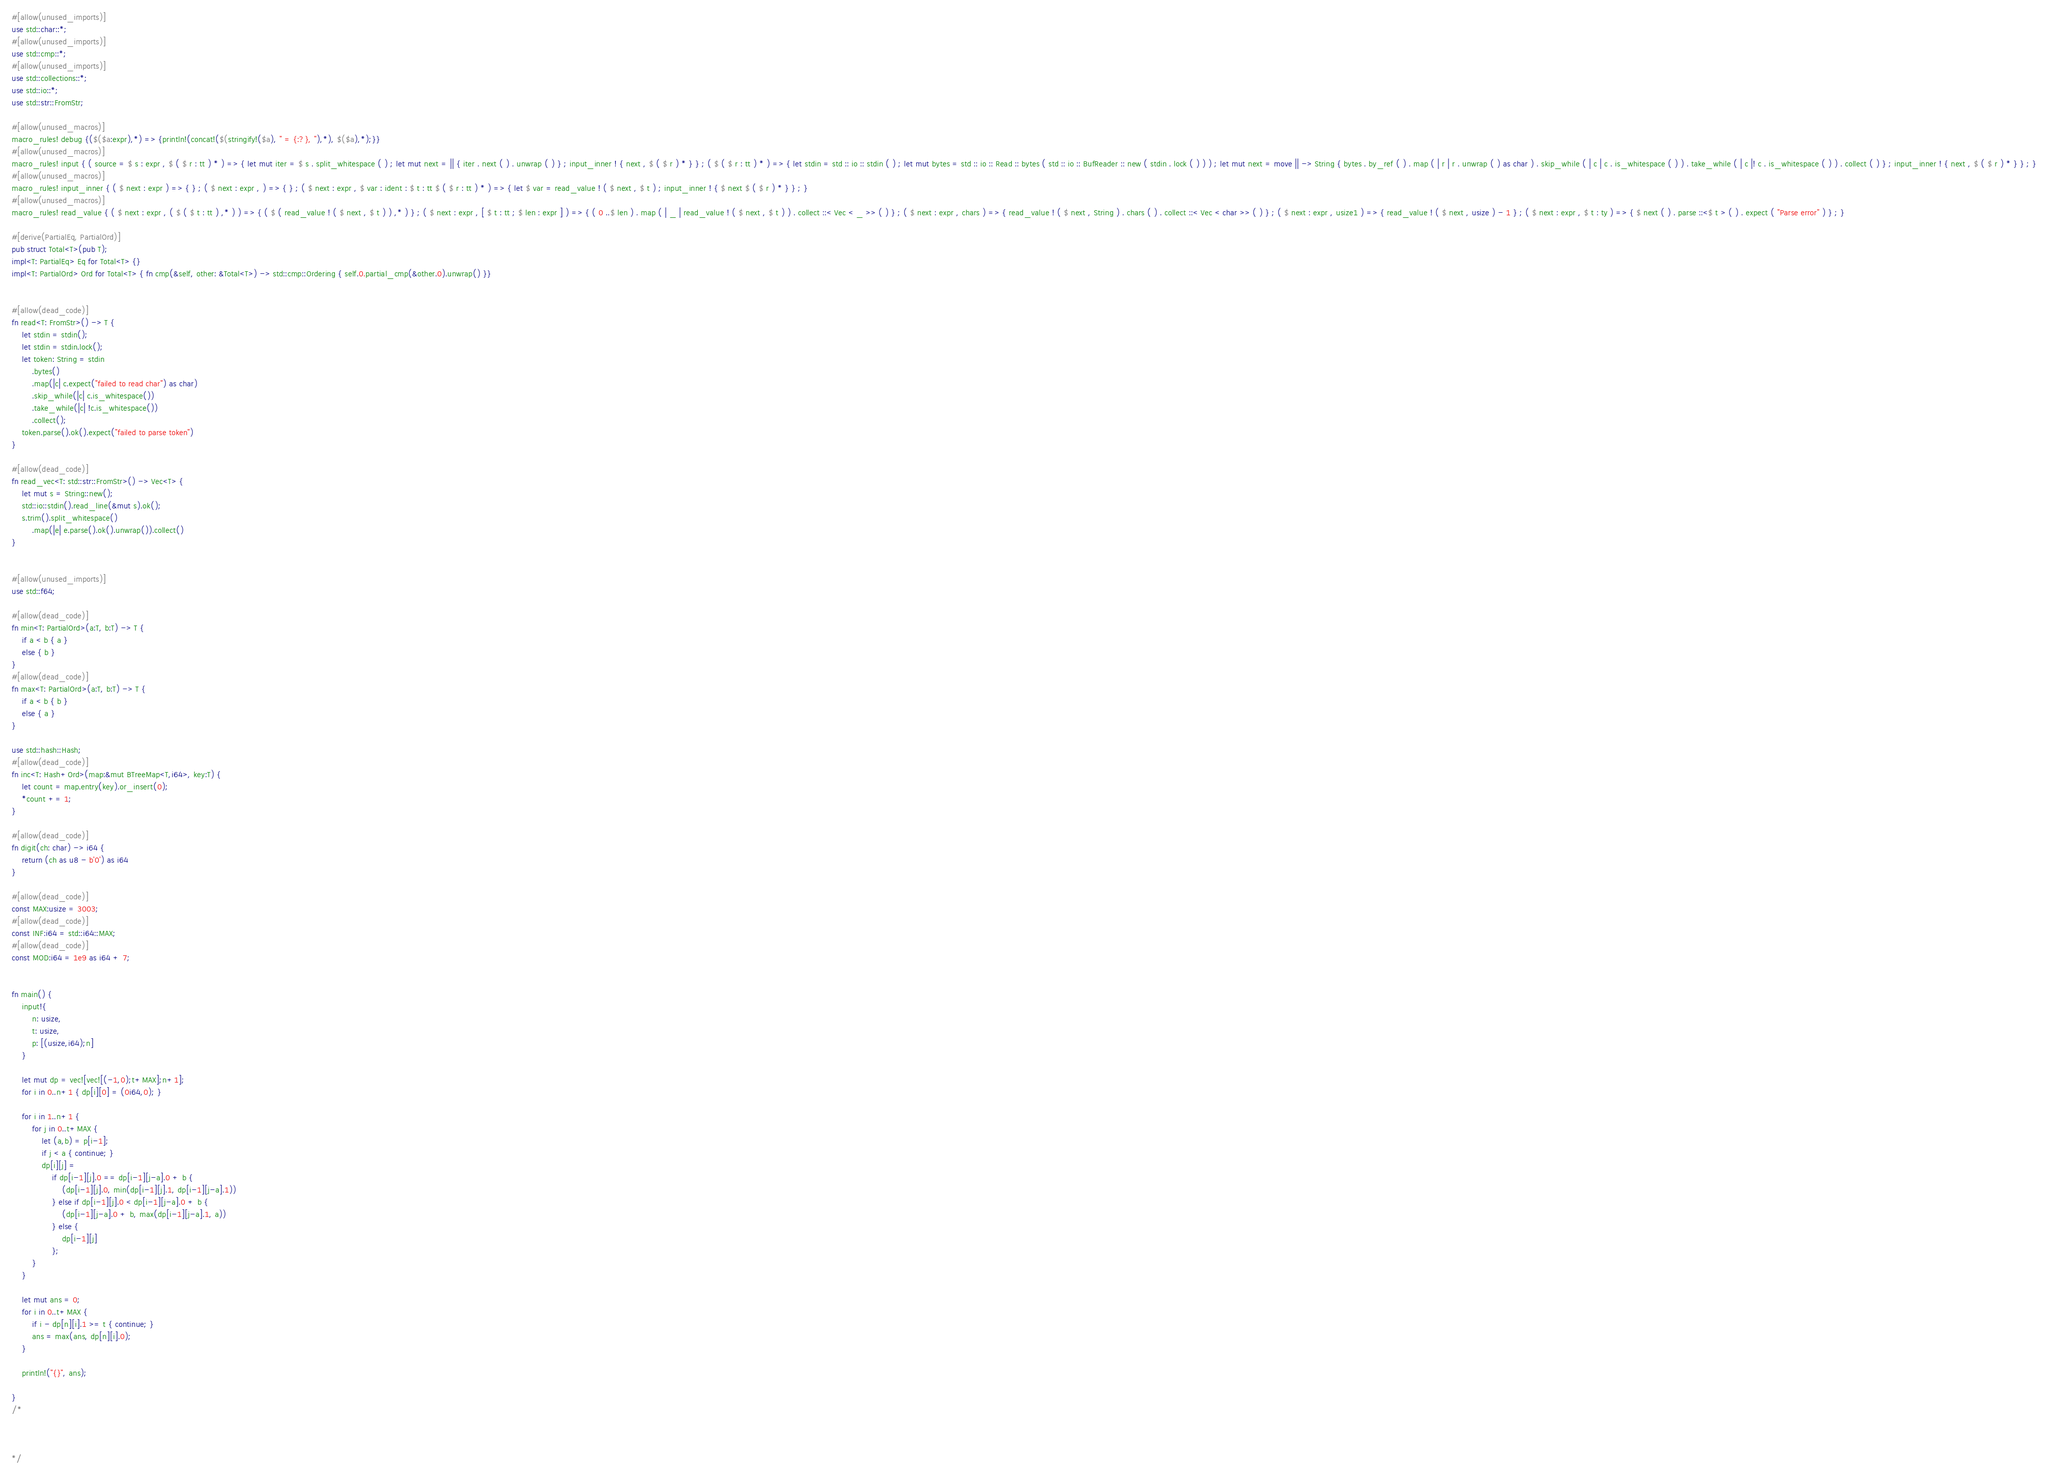Convert code to text. <code><loc_0><loc_0><loc_500><loc_500><_Rust_>#[allow(unused_imports)]
use std::char::*;
#[allow(unused_imports)]
use std::cmp::*;
#[allow(unused_imports)]
use std::collections::*;
use std::io::*;
use std::str::FromStr;

#[allow(unused_macros)]
macro_rules! debug {($($a:expr),*) => {println!(concat!($(stringify!($a), " = {:?}, "),*), $($a),*);}}
#[allow(unused_macros)]
macro_rules! input { ( source = $ s : expr , $ ( $ r : tt ) * ) => { let mut iter = $ s . split_whitespace ( ) ; let mut next = || { iter . next ( ) . unwrap ( ) } ; input_inner ! { next , $ ( $ r ) * } } ; ( $ ( $ r : tt ) * ) => { let stdin = std :: io :: stdin ( ) ; let mut bytes = std :: io :: Read :: bytes ( std :: io :: BufReader :: new ( stdin . lock ( ) ) ) ; let mut next = move || -> String { bytes . by_ref ( ) . map ( | r | r . unwrap ( ) as char ) . skip_while ( | c | c . is_whitespace ( ) ) . take_while ( | c |! c . is_whitespace ( ) ) . collect ( ) } ; input_inner ! { next , $ ( $ r ) * } } ; }
#[allow(unused_macros)]
macro_rules! input_inner { ( $ next : expr ) => { } ; ( $ next : expr , ) => { } ; ( $ next : expr , $ var : ident : $ t : tt $ ( $ r : tt ) * ) => { let $ var = read_value ! ( $ next , $ t ) ; input_inner ! { $ next $ ( $ r ) * } } ; }
#[allow(unused_macros)]
macro_rules! read_value { ( $ next : expr , ( $ ( $ t : tt ) ,* ) ) => { ( $ ( read_value ! ( $ next , $ t ) ) ,* ) } ; ( $ next : expr , [ $ t : tt ; $ len : expr ] ) => { ( 0 ..$ len ) . map ( | _ | read_value ! ( $ next , $ t ) ) . collect ::< Vec < _ >> ( ) } ; ( $ next : expr , chars ) => { read_value ! ( $ next , String ) . chars ( ) . collect ::< Vec < char >> ( ) } ; ( $ next : expr , usize1 ) => { read_value ! ( $ next , usize ) - 1 } ; ( $ next : expr , $ t : ty ) => { $ next ( ) . parse ::<$ t > ( ) . expect ( "Parse error" ) } ; }

#[derive(PartialEq, PartialOrd)]
pub struct Total<T>(pub T);
impl<T: PartialEq> Eq for Total<T> {}
impl<T: PartialOrd> Ord for Total<T> { fn cmp(&self, other: &Total<T>) -> std::cmp::Ordering { self.0.partial_cmp(&other.0).unwrap() }}


#[allow(dead_code)]
fn read<T: FromStr>() -> T {
    let stdin = stdin();
    let stdin = stdin.lock();
    let token: String = stdin
        .bytes()
        .map(|c| c.expect("failed to read char") as char)
        .skip_while(|c| c.is_whitespace())
        .take_while(|c| !c.is_whitespace())
        .collect();
    token.parse().ok().expect("failed to parse token")
}

#[allow(dead_code)]
fn read_vec<T: std::str::FromStr>() -> Vec<T> {
    let mut s = String::new();
    std::io::stdin().read_line(&mut s).ok();
    s.trim().split_whitespace()
        .map(|e| e.parse().ok().unwrap()).collect()
}


#[allow(unused_imports)]
use std::f64;

#[allow(dead_code)]
fn min<T: PartialOrd>(a:T, b:T) -> T {
    if a < b { a }
    else { b }
}
#[allow(dead_code)]
fn max<T: PartialOrd>(a:T, b:T) -> T {
    if a < b { b }
    else { a }
}

use std::hash::Hash;
#[allow(dead_code)]
fn inc<T: Hash+Ord>(map:&mut BTreeMap<T,i64>, key:T) {
    let count = map.entry(key).or_insert(0);
    *count += 1;
}

#[allow(dead_code)]
fn digit(ch: char) -> i64 {
    return (ch as u8 - b'0') as i64
}

#[allow(dead_code)]
const MAX:usize = 3003;
#[allow(dead_code)]
const INF:i64 = std::i64::MAX;
#[allow(dead_code)]
const MOD:i64 = 1e9 as i64 + 7;


fn main() {
    input!{
        n: usize,
        t: usize,
        p: [(usize,i64);n]
    }

    let mut dp = vec![vec![(-1,0);t+MAX];n+1];
    for i in 0..n+1 { dp[i][0] = (0i64,0); }

    for i in 1..n+1 {
        for j in 0..t+MAX {
            let (a,b) = p[i-1];
            if j < a { continue; }
            dp[i][j] =
                if dp[i-1][j].0 == dp[i-1][j-a].0 + b {
                    (dp[i-1][j].0, min(dp[i-1][j].1, dp[i-1][j-a].1))
                } else if dp[i-1][j].0 < dp[i-1][j-a].0 + b {
                    (dp[i-1][j-a].0 + b, max(dp[i-1][j-a].1, a))
                } else {
                    dp[i-1][j]
                };
        }
    }

    let mut ans = 0;
    for i in 0..t+MAX {
        if i - dp[n][i].1 >= t { continue; }
        ans = max(ans, dp[n][i].0);
    }

    println!("{}", ans);

}
/*



*/
</code> 